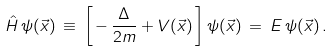Convert formula to latex. <formula><loc_0><loc_0><loc_500><loc_500>\hat { H } \, \psi ( \vec { x } ) \, \equiv \, \left [ \, - \, \frac { \Delta } { 2 m } + V ( \vec { x } ) \, \right ] \psi ( \vec { x } ) \, = \, E \, \psi ( \vec { x } ) \, .</formula> 